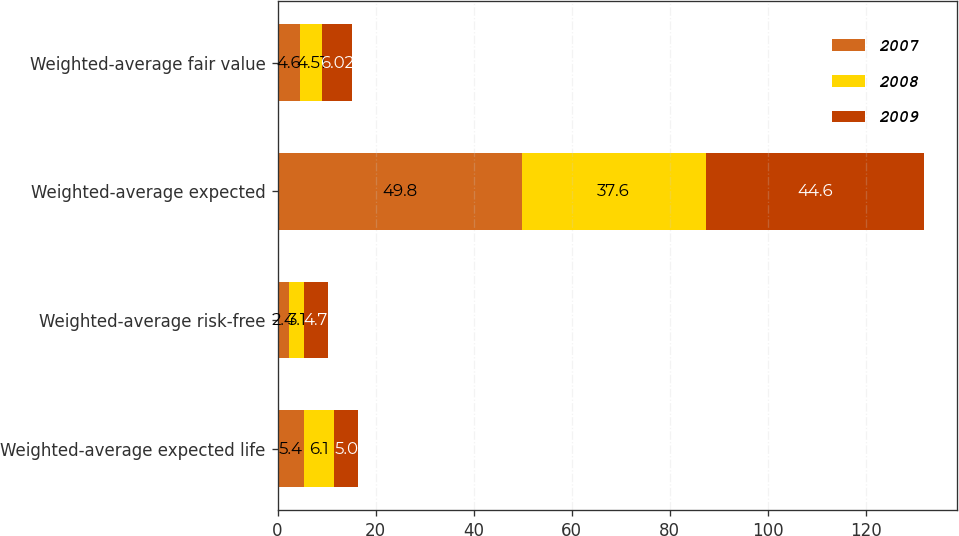Convert chart. <chart><loc_0><loc_0><loc_500><loc_500><stacked_bar_chart><ecel><fcel>Weighted-average expected life<fcel>Weighted-average risk-free<fcel>Weighted-average expected<fcel>Weighted-average fair value<nl><fcel>2007<fcel>5.4<fcel>2.4<fcel>49.8<fcel>4.6<nl><fcel>2008<fcel>6.1<fcel>3.1<fcel>37.6<fcel>4.51<nl><fcel>2009<fcel>5<fcel>4.7<fcel>44.6<fcel>6.02<nl></chart> 